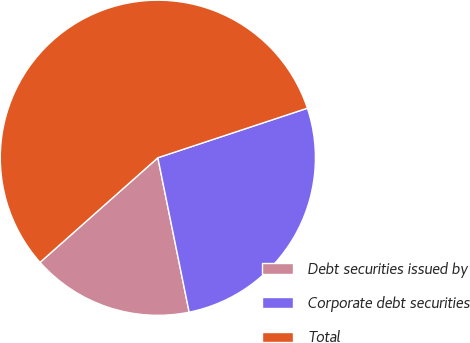<chart> <loc_0><loc_0><loc_500><loc_500><pie_chart><fcel>Debt securities issued by<fcel>Corporate debt securities<fcel>Total<nl><fcel>16.63%<fcel>26.91%<fcel>56.47%<nl></chart> 